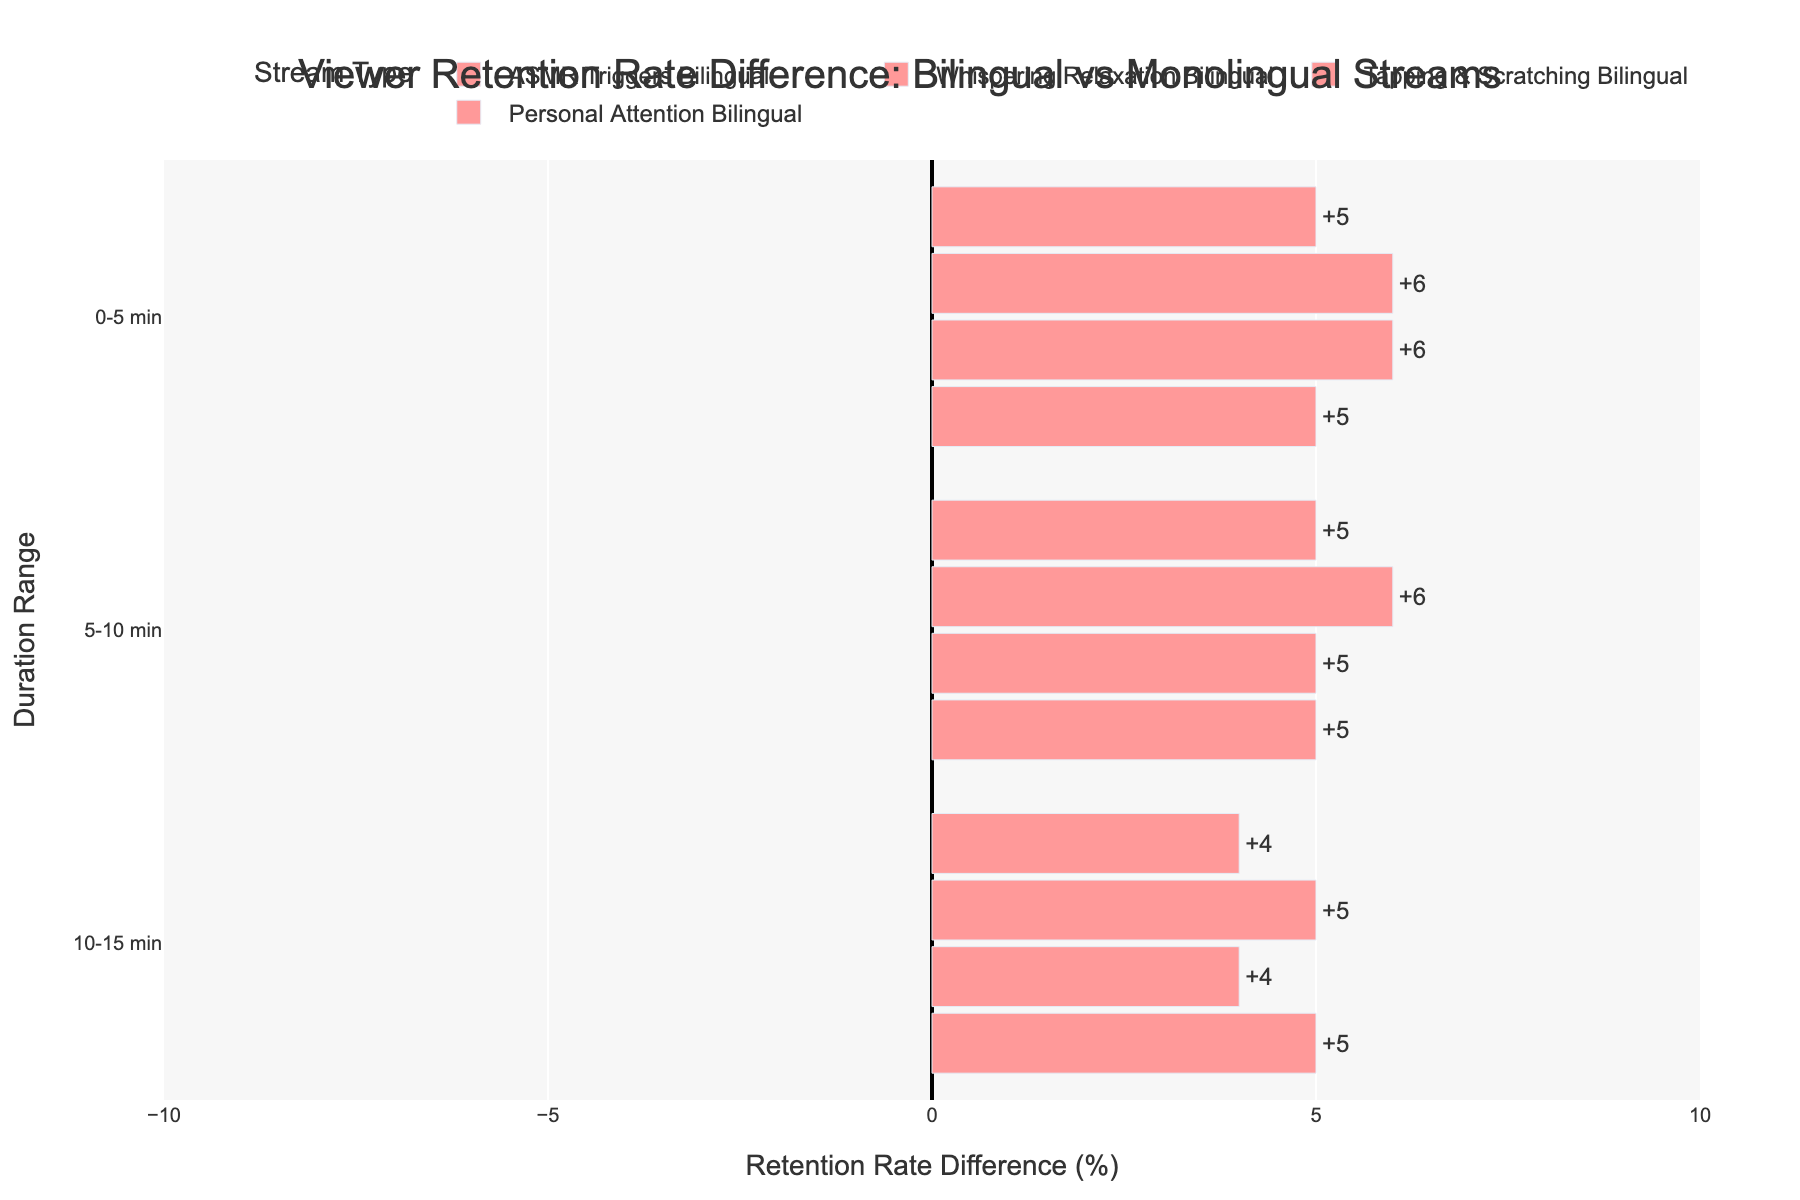What is the retention rate difference for "Personal Attention Bilingual" during the 0-5 min duration range? The bar for "Personal Attention Bilingual" during the 0-5 min range shows a positive difference. To determine the exact value, look at the length of the bar in that category, which reads +5%.
Answer: +5% Which stream type has the highest retention rate difference for the 5-10 min duration range? Compare the bar lengths for all stream types in the 5-10 min duration range. The "Personal Attention Bilingual" stream type has the highest positive bar length, showing a difference of +5%.
Answer: Personal Attention Bilingual How does the retention rate difference for "ASMR Triggers Bilingual" compare between the 0-5 min and the 10-15 min duration ranges? Notice the bar lengths for "ASMR Triggers Bilingual" in both the 0-5 min and the 10-15 min duration ranges. In the 0-5 min range, it shows +5%, while in the 10-15 min range, it shows +5%. Both have a difference of +5%, indicating the same retention difference.
Answer: Same What is the color of the bar indicating the retention rate difference for "Whispering Relaxation Bilingual" during the 0-5 min duration range, and what does it imply? The bar for "Whispering Relaxation Bilingual" at the 0-5 min range is red. Red indicates a positive difference, meaning higher retention for bilingual streams compared to monolingual.
Answer: Red, positive difference For which duration range does the "Tapping & Scratching Bilingual" stream show a consistent retention rate difference of more than 5% over the monolingual streams? Evaluate the lengths of the "Tapping & Scratching Bilingual" bars across all duration ranges. In the 0-5 min and 5-10 min ranges, the retention rate differences are +6% and +6%, respectively. Therefore, these ranges show a consistent difference of more than 5%.
Answer: 0-5 min and 5-10 min 